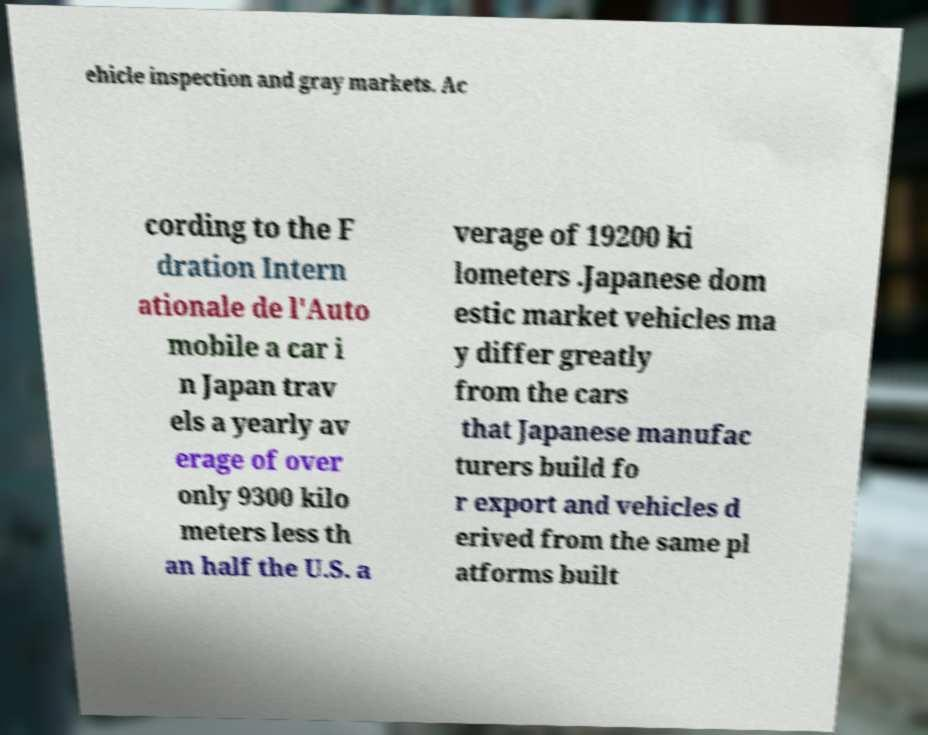Can you read and provide the text displayed in the image?This photo seems to have some interesting text. Can you extract and type it out for me? ehicle inspection and gray markets. Ac cording to the F dration Intern ationale de l'Auto mobile a car i n Japan trav els a yearly av erage of over only 9300 kilo meters less th an half the U.S. a verage of 19200 ki lometers .Japanese dom estic market vehicles ma y differ greatly from the cars that Japanese manufac turers build fo r export and vehicles d erived from the same pl atforms built 